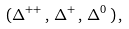<formula> <loc_0><loc_0><loc_500><loc_500>( \Delta ^ { + + } \, , \, \Delta ^ { + } \, , \, \Delta ^ { 0 } \, ) \, ,</formula> 